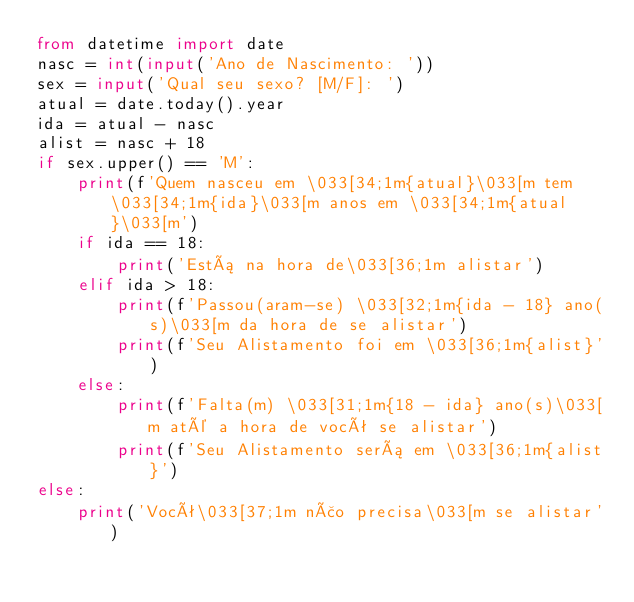Convert code to text. <code><loc_0><loc_0><loc_500><loc_500><_Python_>from datetime import date
nasc = int(input('Ano de Nascimento: '))
sex = input('Qual seu sexo? [M/F]: ')
atual = date.today().year
ida = atual - nasc
alist = nasc + 18
if sex.upper() == 'M':
    print(f'Quem nasceu em \033[34;1m{atual}\033[m tem \033[34;1m{ida}\033[m anos em \033[34;1m{atual}\033[m')
    if ida == 18:
        print('Está na hora de\033[36;1m alistar')
    elif ida > 18:
        print(f'Passou(aram-se) \033[32;1m{ida - 18} ano(s)\033[m da hora de se alistar')
        print(f'Seu Alistamento foi em \033[36;1m{alist}')
    else:
        print(f'Falta(m) \033[31;1m{18 - ida} ano(s)\033[m até a hora de você se alistar')
        print(f'Seu Alistamento será em \033[36;1m{alist}')
else:
    print('Você\033[37;1m não precisa\033[m se alistar')
</code> 